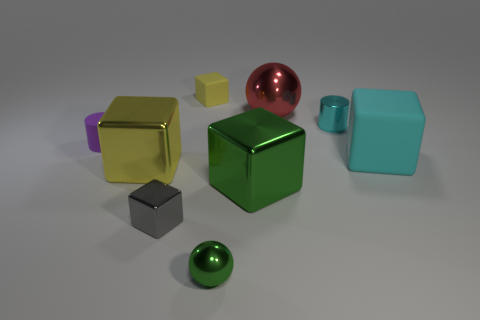Is there any other thing that has the same color as the tiny matte cylinder?
Ensure brevity in your answer.  No. What is the size of the green cube left of the matte cube that is in front of the small block behind the cyan block?
Keep it short and to the point. Large. There is a shiny thing that is both in front of the purple cylinder and on the right side of the small green object; what is its color?
Offer a terse response. Green. How big is the cylinder that is left of the tiny green object?
Give a very brief answer. Small. How many tiny gray cubes are the same material as the green ball?
Provide a short and direct response. 1. There is a rubber thing that is the same color as the small metallic cylinder; what is its shape?
Ensure brevity in your answer.  Cube. Do the tiny rubber thing behind the purple rubber object and the tiny green metallic object have the same shape?
Your response must be concise. No. What is the color of the small cylinder that is made of the same material as the gray block?
Keep it short and to the point. Cyan. There is a matte cube to the right of the big metallic cube to the right of the yellow shiny block; is there a green cube behind it?
Ensure brevity in your answer.  No. The tiny cyan object has what shape?
Your response must be concise. Cylinder. 